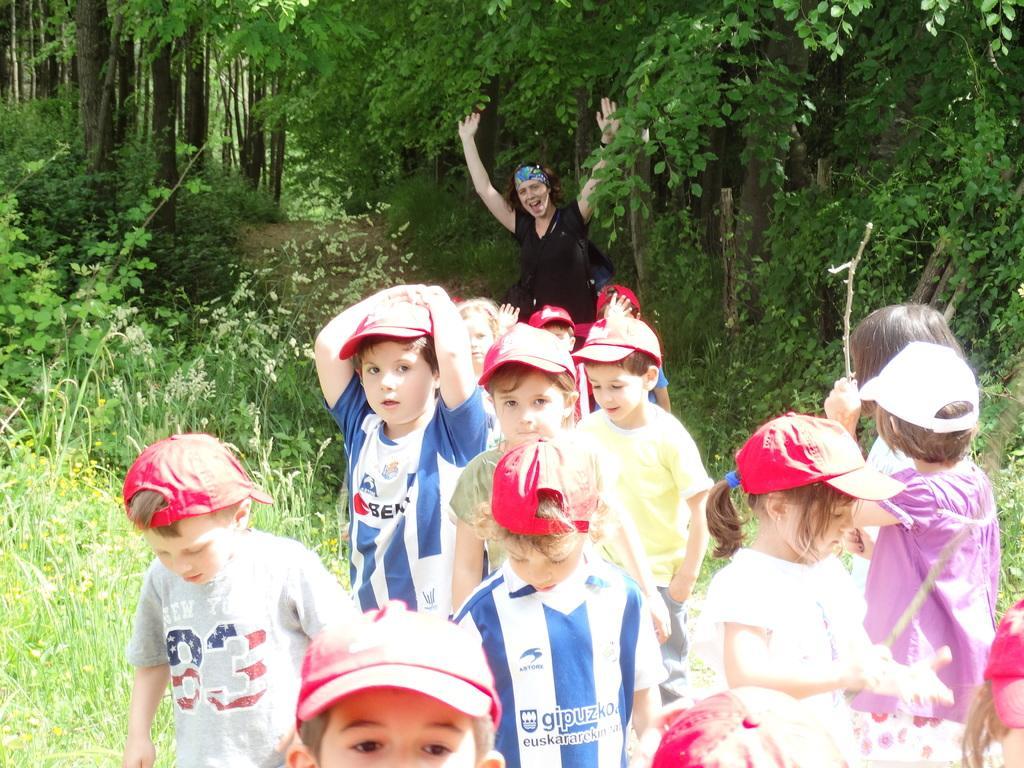How would you summarize this image in a sentence or two? In this picture we can see there is a group of kids and a person. Behind the people, there are trees and grass. 